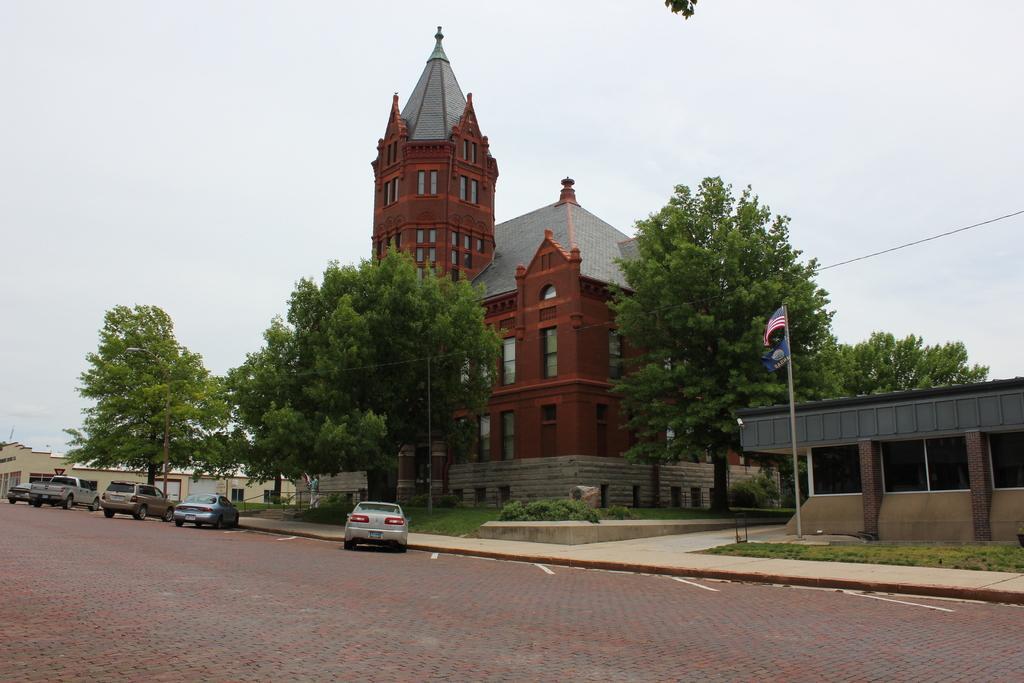How would you summarize this image in a sentence or two? There is a road in the foreground area of the image, there are trees, houses, vehicles and the sky in the background. 